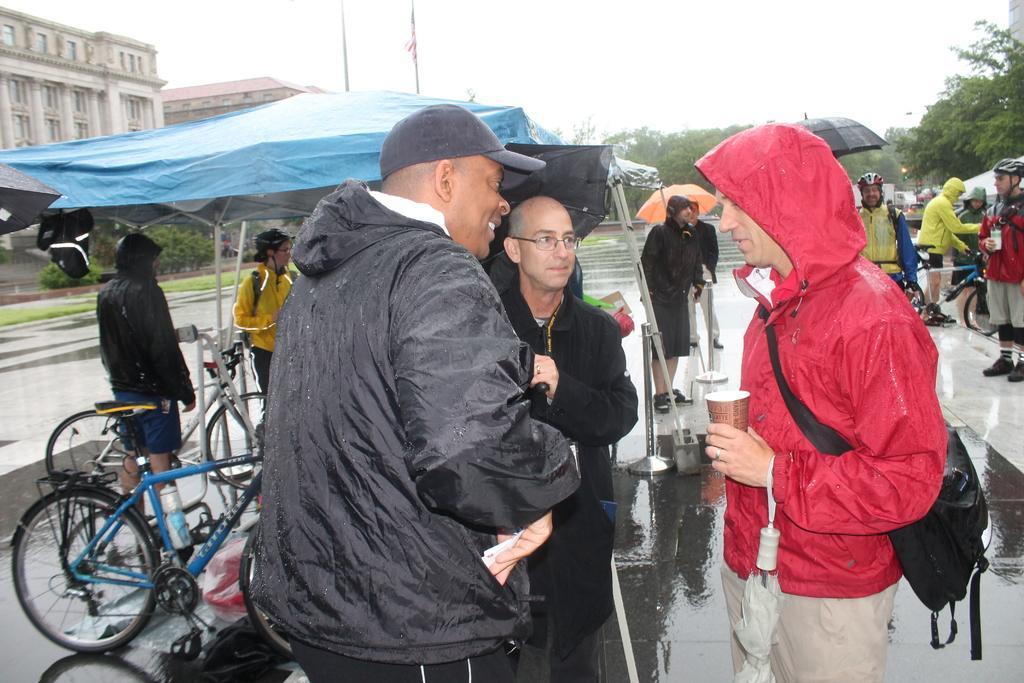How would you summarize this image in a sentence or two? In this image, we can see people wearing coats and some are wearing caps, helmets, bags and some of them are holding umbrellas and some other objects. In the background, there are buildings, trees, tents, bicycles, poles, stands and lights. At the bottom, there is a road and at the top, there is sky. 